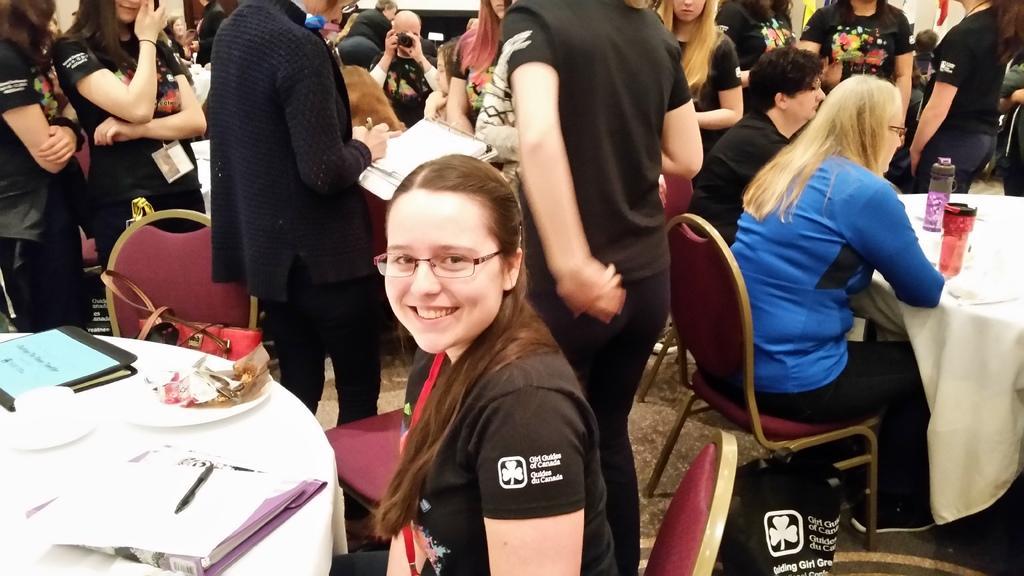Could you give a brief overview of what you see in this image? here in this picture we can see woman sitting on the chair in front of a table with a paper pen on the table,we can also see some of the items on the table,we can see group of people behind her standing and some are sitting,we can see water bottles on the table. 